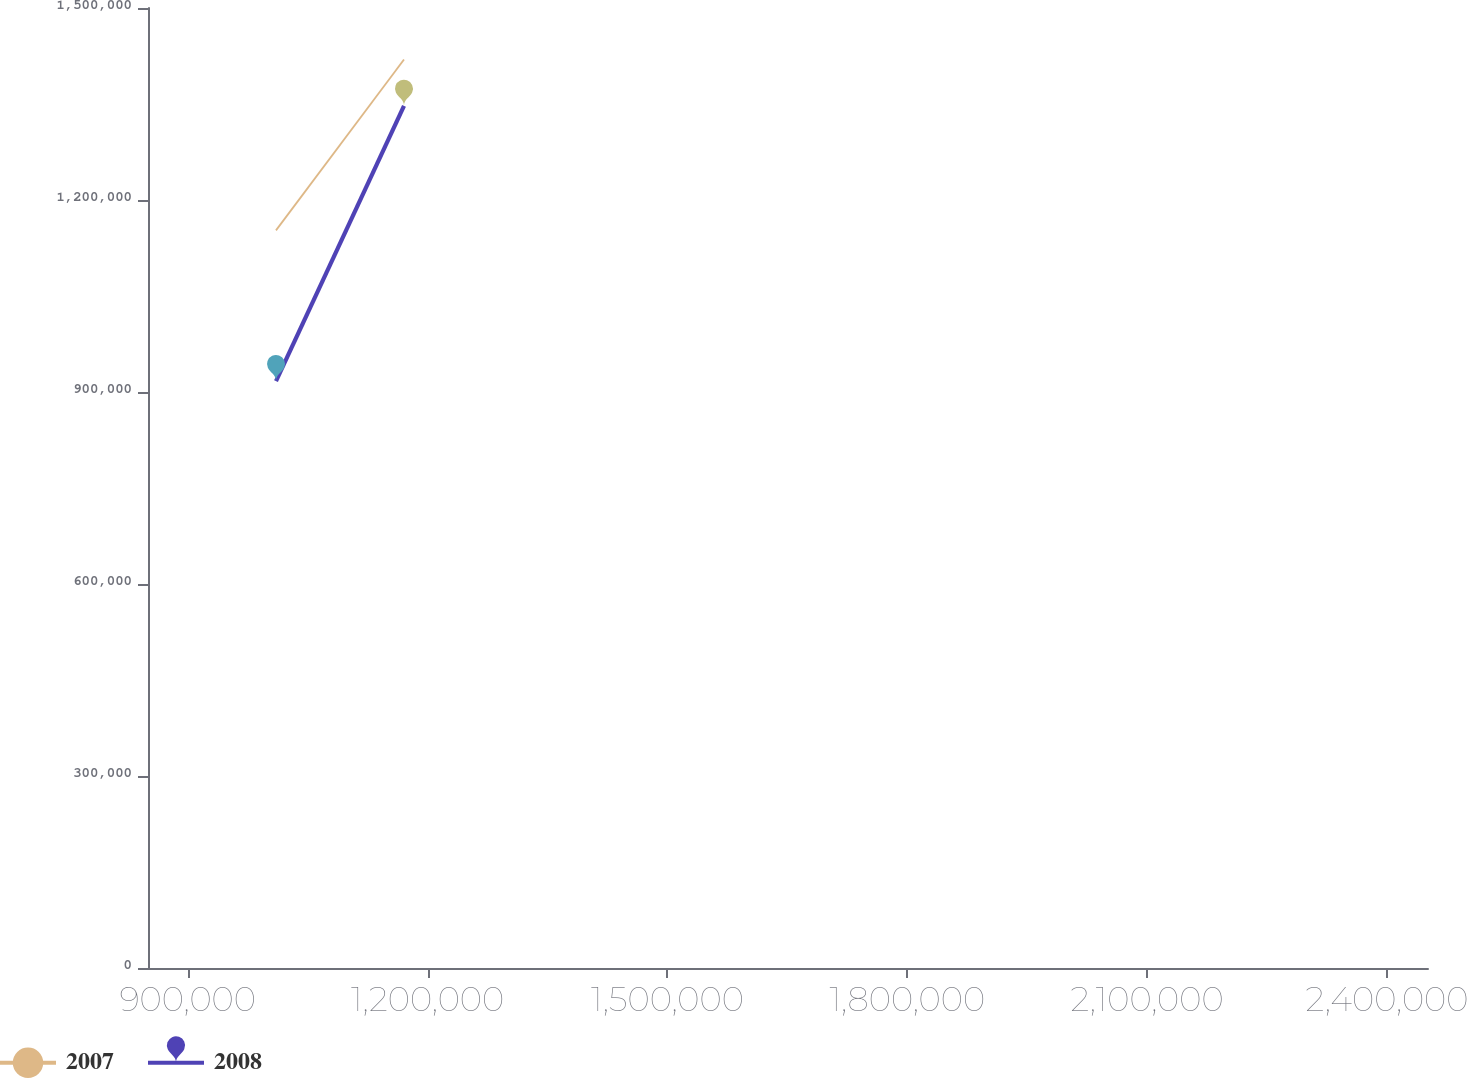Convert chart. <chart><loc_0><loc_0><loc_500><loc_500><line_chart><ecel><fcel>2007<fcel>2008<nl><fcel>1.01043e+06<fcel>1.15259e+06<fcel>917019<nl><fcel>1.17053e+06<fcel>1.41949e+06<fcel>1.34704e+06<nl><fcel>2.61146e+06<fcel>2.09639e+06<fcel>2.04091e+06<nl></chart> 